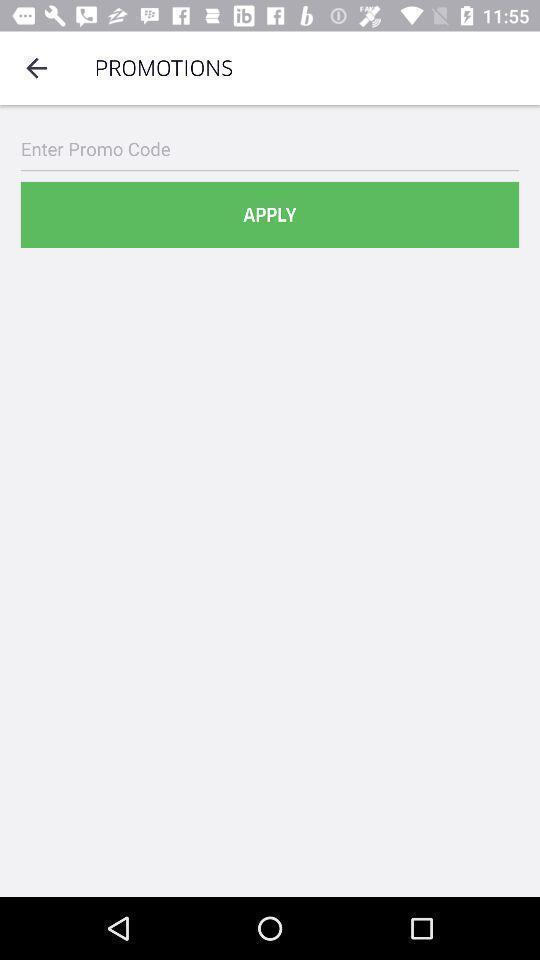Describe the content in this image. Screen shows to apply promotions. 